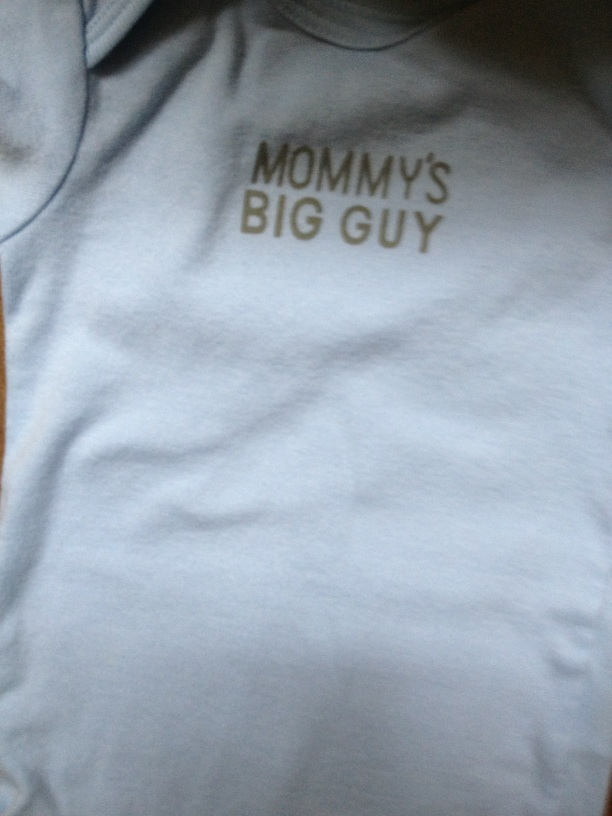Can you describe the design and text on the shirt? The shirt is light blue with a simple design. It features the text 'Mommy's Big Guy' in bold, dark letters across the chest. 